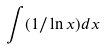Convert formula to latex. <formula><loc_0><loc_0><loc_500><loc_500>\int ( 1 / \ln x ) d x</formula> 